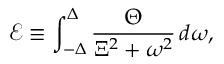Convert formula to latex. <formula><loc_0><loc_0><loc_500><loc_500>\mathcal { E } \equiv \int _ { - \Delta } ^ { \Delta } \frac { \Theta } { \Xi ^ { 2 } + \omega ^ { 2 } } \, d \omega ,</formula> 